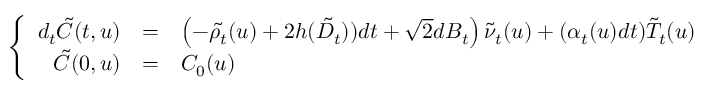Convert formula to latex. <formula><loc_0><loc_0><loc_500><loc_500>\left \{ \begin{array} { r c l } { d _ { t } { \tilde { C } } ( t , u ) } & { = } & { \left ( - \tilde { \rho _ { t } } ( u ) + 2 h ( \tilde { D _ { t } } ) ) d t + \sqrt { 2 } d B _ { t } \right ) \tilde { \nu } _ { t } ( u ) + ( \alpha _ { t } ( u ) d t ) \tilde { T } _ { t } ( u ) } \\ { { \tilde { C } } ( 0 , u ) } & { = } & { C _ { 0 } ( u ) } \end{array}</formula> 